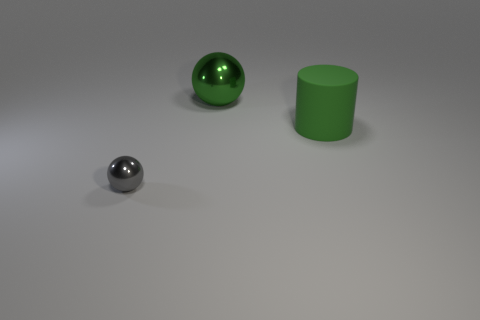How many other objects are there of the same color as the small thing?
Your answer should be compact. 0. Is the material of the green cylinder the same as the sphere behind the gray thing?
Provide a succinct answer. No. There is a big object behind the large rubber cylinder to the right of the tiny thing; how many rubber things are to the right of it?
Offer a very short reply. 1. Are there fewer gray objects on the right side of the small metallic ball than cylinders in front of the big rubber object?
Your response must be concise. No. How many other things are the same material as the cylinder?
Offer a very short reply. 0. There is a green ball that is the same size as the cylinder; what is it made of?
Give a very brief answer. Metal. What number of blue objects are either large metal cylinders or shiny spheres?
Offer a terse response. 0. There is a thing that is both left of the green matte cylinder and on the right side of the tiny metal sphere; what color is it?
Your response must be concise. Green. Are the sphere behind the small gray sphere and the big green thing that is to the right of the large metal ball made of the same material?
Keep it short and to the point. No. Are there more tiny metallic objects that are in front of the gray ball than green metallic balls in front of the large ball?
Ensure brevity in your answer.  No. 